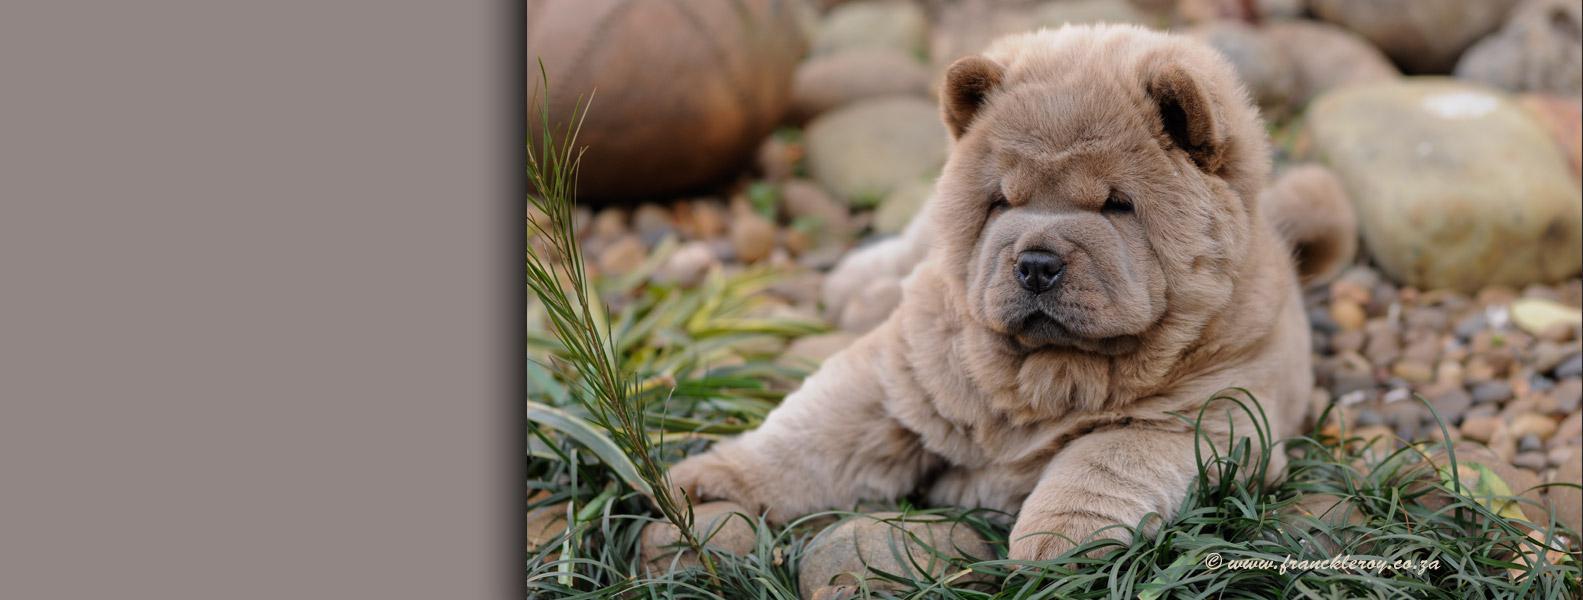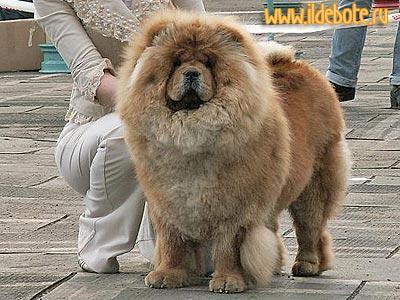The first image is the image on the left, the second image is the image on the right. For the images displayed, is the sentence "There are two dogs standing on four legs." factually correct? Answer yes or no. No. The first image is the image on the left, the second image is the image on the right. Examine the images to the left and right. Is the description "One image features a person behind a chow posed standing on all fours and looking toward the camera." accurate? Answer yes or no. Yes. 